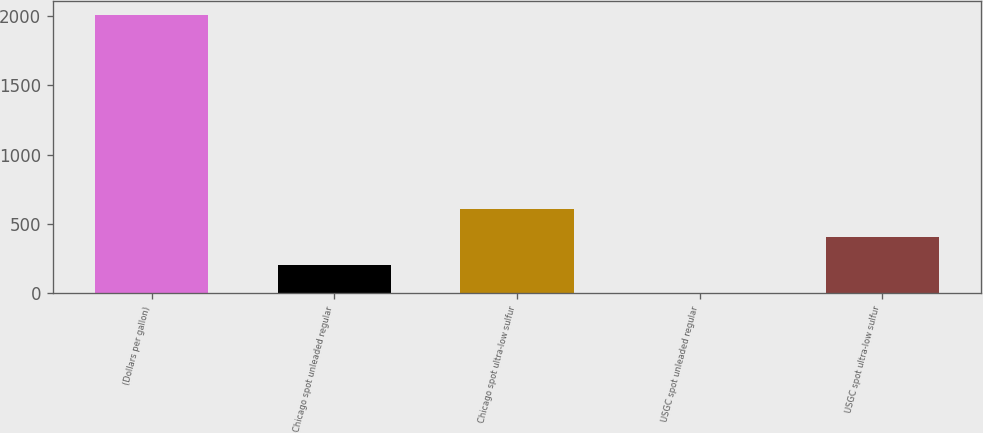<chart> <loc_0><loc_0><loc_500><loc_500><bar_chart><fcel>(Dollars per gallon)<fcel>Chicago spot unleaded regular<fcel>Chicago spot ultra-low sulfur<fcel>USGC spot unleaded regular<fcel>USGC spot ultra-low sulfur<nl><fcel>2011<fcel>203.58<fcel>605.24<fcel>2.75<fcel>404.41<nl></chart> 